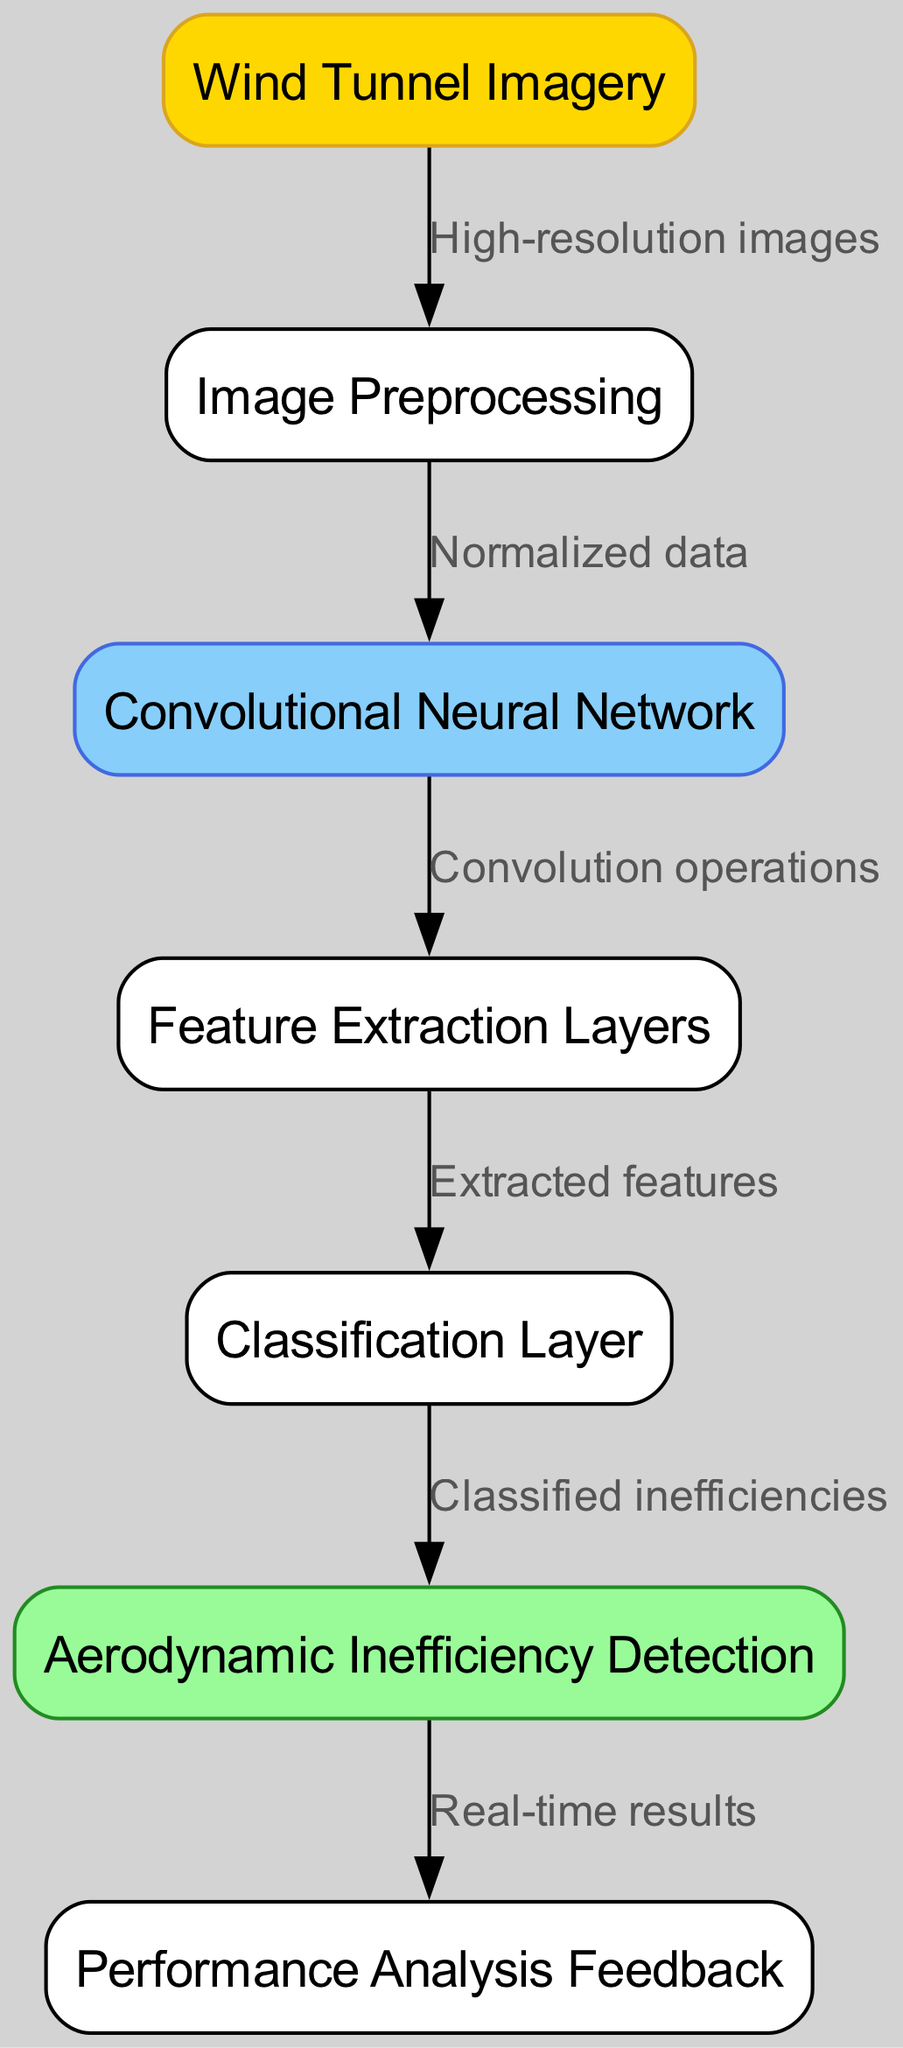What is the initial input type in this diagram? The diagram starts with the "Wind Tunnel Imagery" node, which is the first element and indicates the type of input being processed.
Answer: Wind Tunnel Imagery How many nodes are present in the diagram? By counting the nodes listed—there are six distinct nodes in total that represent different stages of the process in the neural network.
Answer: Six What is the function of the classification layer? Following the flow of the diagram, the "Classification Layer" node takes the output from the "Feature Extraction Layers" and processes it to classify inefficiencies in car aerodynamics.
Answer: Classified inefficiencies What do the edges in this diagram represent? The edges in the diagram represent the connections and flow of data between different nodes, showing how information is transferred from one stage to the next in the ML process.
Answer: Data flow What layer follows the feature extraction layer? The diagram illustrates that after the "Feature Extraction Layers," the process moves to the "Classification Layer," indicating the sequential order of operations in the neural network.
Answer: Classification Layer What type of feedback is generated after the output? The output from the detection phase provides "Performance Analysis Feedback," which indicates the real-time effectiveness of the detection process for aerodynamic inefficiencies.
Answer: Performance Analysis Feedback Which node outputs real-time results? In the flow of the diagram, the "Output" node connects to "Performance Analysis Feedback," indicating that this layer provides real-time results based on the processed input data.
Answer: Output What processes occur after image preprocessing? After the "Image Preprocessing" step, the diagram shows that normalized data is passed to the "Convolutional Neural Network," initiating the model’s processing phase.
Answer: Convolutional Neural Network Which layer is responsible for feature extraction? The specific node labeled "Feature Extraction Layers" is designated in the diagram for the task of extracting relevant features from the data that flows through the neural network.
Answer: Feature Extraction Layers 